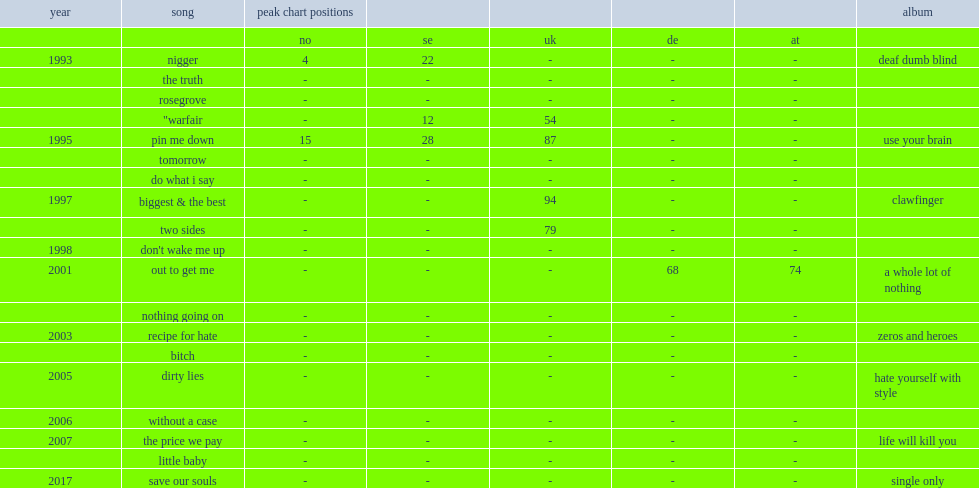When did clawfinger's single "do what i say" release? 1995.0. 